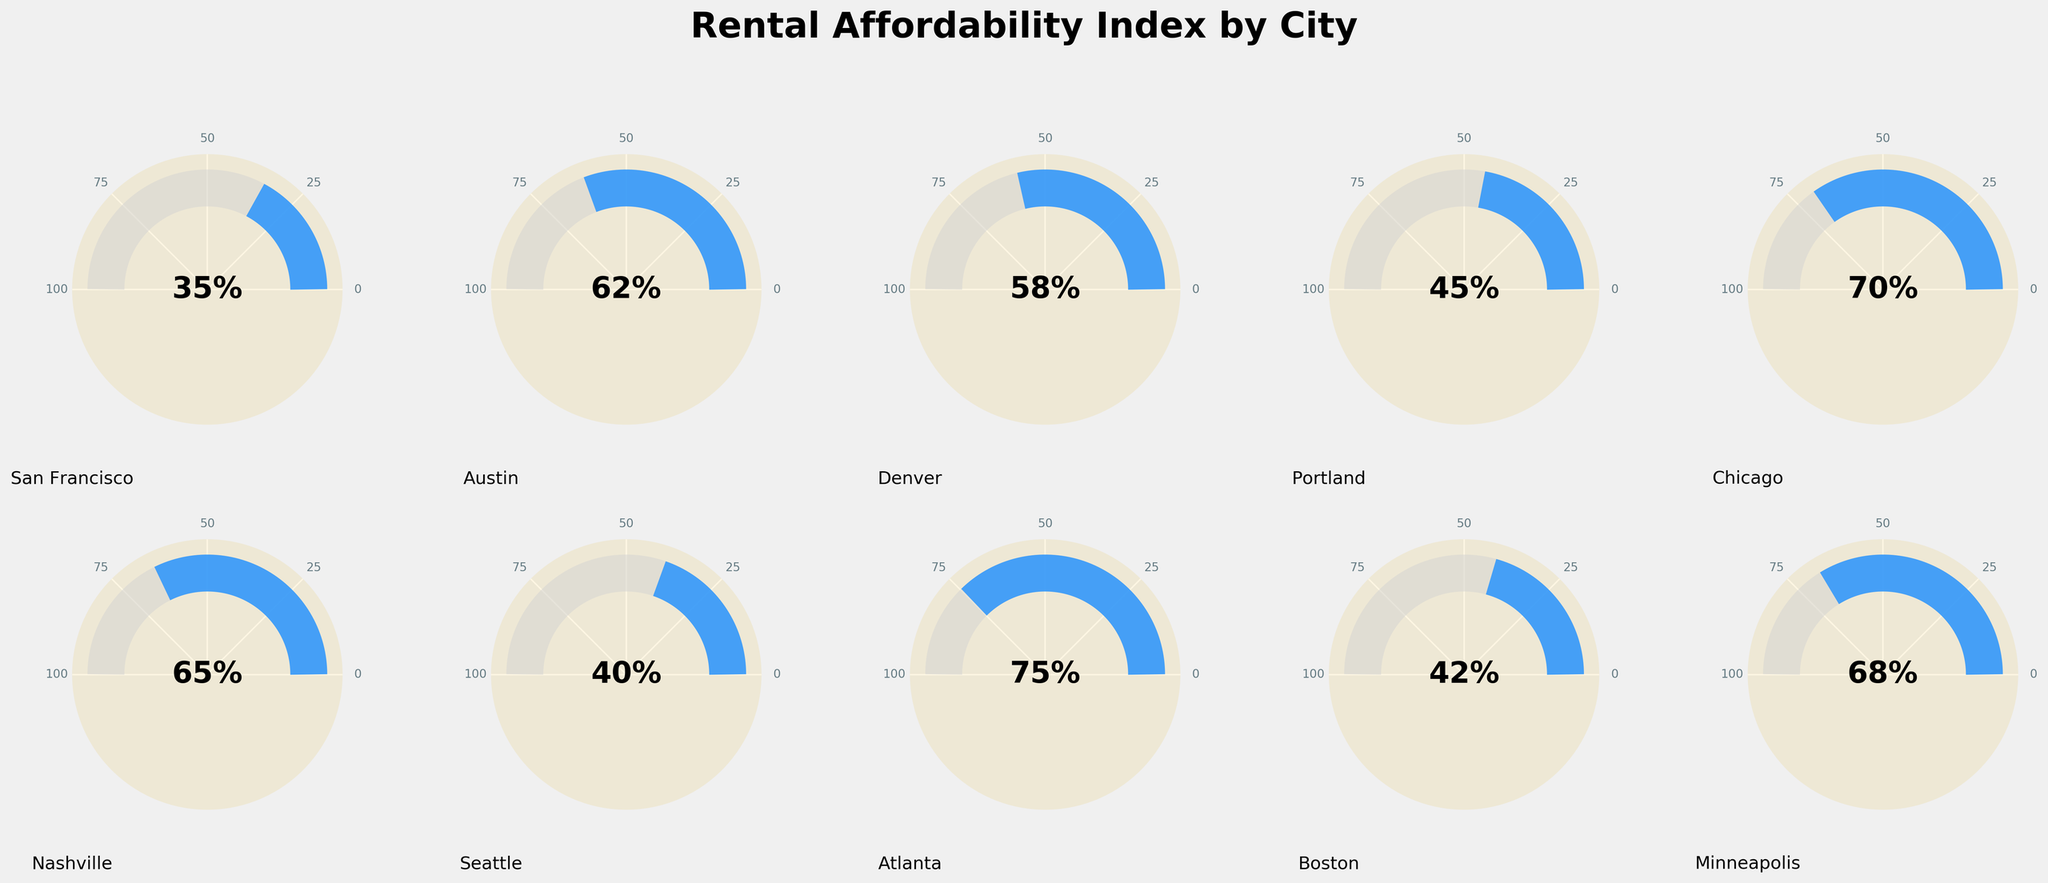What's the title of the figure? The title is usually placed at the top of the figure, and it provides a summary of what the figure is about. Here, it is clearly written at the top in a large font.
Answer: Rental Affordability Index by City Which city has the highest affordability index? The highest affordability index can be determined by looking for the city with the gauge filled the most towards 100%. From the figure, Atlanta has the gauge filled up to 75%.
Answer: Atlanta Which city has the lowest affordability index? The lowest affordability index can be identified by finding the city with the least filled gauge towards 0%. According to the figure, San Francisco has the gauge filled up to 35%.
Answer: San Francisco What is the average affordability index of all the cities? To find the average, sum all the affordability index values and divide by the number of cities. (35 + 62 + 58 + 45 + 70 + 65 + 40 + 75 + 42 + 68)/10 = 56
Answer: 56 How many cities have an affordability index of 50% or more? Count the cities with the gauge filled to 50% or more. They are Austin, Denver, Chicago, Nashville, Atlanta, and Minneapolis. There are 6 such cities.
Answer: 6 Which cities have an affordability index less than 50%? Identify the cities whose gauge is filled less than halfway. The cities are San Francisco, Portland, Seattle, and Boston.
Answer: San Francisco, Portland, Seattle, Boston What is the difference between the highest and lowest affordability index? Subtract the lowest value from the highest value. The highest is 75 (Atlanta) and the lowest is 35 (San Francisco). 75 - 35 = 40
Answer: 40 Which cities have an affordability index exactly between 40% and 60%? Look for cities with the gauge filled between 40% and 60%. The cities are Denver, Portland, Seattle, and Boston which falls exactly between 40% and 60%.
Answer: Denver, Portland, Seattle, Boston Is the affordability index for Seattle higher or lower than Boston? Comparing the gauge fill, Seattle is at 40% while Boston is at 42%. Hence, Seattle's index is lower than Boston's.
Answer: Lower What is the combined affordability index for Chicago and Minneapolis? Add the affordability index values for Chicago and Minneapolis: 70 + 68 = 138
Answer: 138 